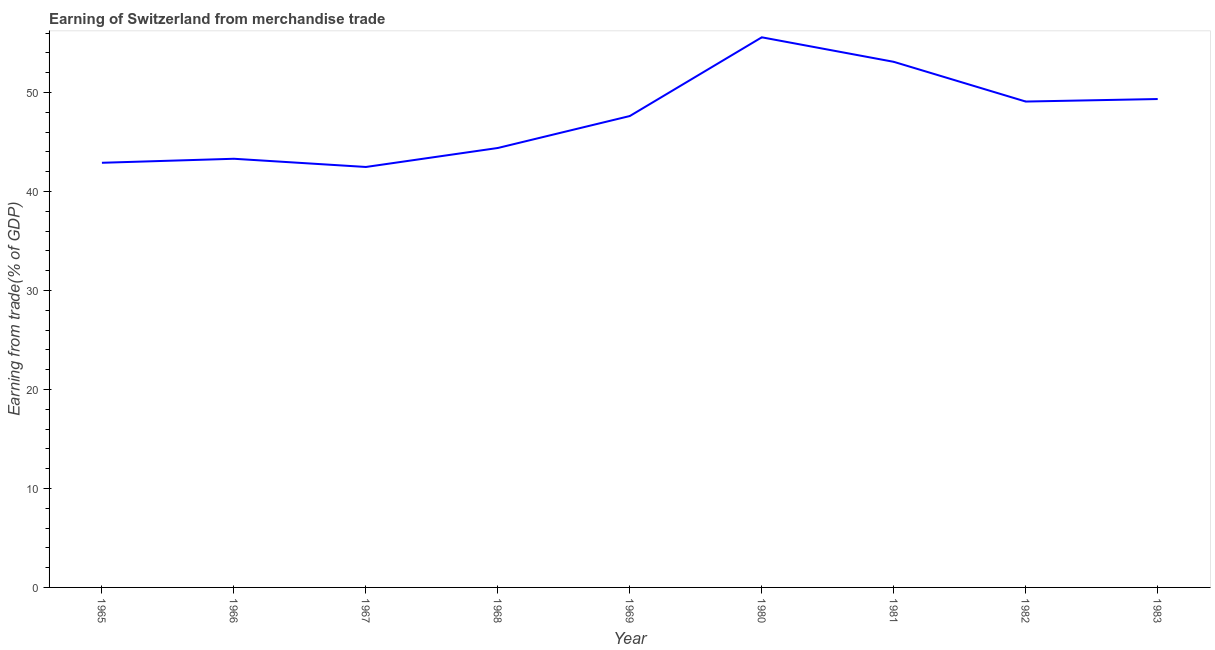What is the earning from merchandise trade in 1966?
Make the answer very short. 43.3. Across all years, what is the maximum earning from merchandise trade?
Your answer should be very brief. 55.57. Across all years, what is the minimum earning from merchandise trade?
Your answer should be compact. 42.48. In which year was the earning from merchandise trade maximum?
Give a very brief answer. 1980. In which year was the earning from merchandise trade minimum?
Offer a very short reply. 1967. What is the sum of the earning from merchandise trade?
Your response must be concise. 427.79. What is the difference between the earning from merchandise trade in 1967 and 1983?
Your response must be concise. -6.86. What is the average earning from merchandise trade per year?
Offer a terse response. 47.53. What is the median earning from merchandise trade?
Make the answer very short. 47.62. In how many years, is the earning from merchandise trade greater than 42 %?
Provide a succinct answer. 9. Do a majority of the years between 1981 and 1969 (inclusive) have earning from merchandise trade greater than 40 %?
Offer a terse response. No. What is the ratio of the earning from merchandise trade in 1967 to that in 1982?
Offer a terse response. 0.87. Is the earning from merchandise trade in 1966 less than that in 1981?
Provide a succinct answer. Yes. What is the difference between the highest and the second highest earning from merchandise trade?
Make the answer very short. 2.48. Is the sum of the earning from merchandise trade in 1968 and 1983 greater than the maximum earning from merchandise trade across all years?
Your answer should be very brief. Yes. What is the difference between the highest and the lowest earning from merchandise trade?
Give a very brief answer. 13.1. How many lines are there?
Provide a short and direct response. 1. What is the difference between two consecutive major ticks on the Y-axis?
Give a very brief answer. 10. Are the values on the major ticks of Y-axis written in scientific E-notation?
Ensure brevity in your answer.  No. Does the graph contain grids?
Offer a terse response. No. What is the title of the graph?
Offer a very short reply. Earning of Switzerland from merchandise trade. What is the label or title of the Y-axis?
Your response must be concise. Earning from trade(% of GDP). What is the Earning from trade(% of GDP) in 1965?
Your answer should be compact. 42.9. What is the Earning from trade(% of GDP) in 1966?
Give a very brief answer. 43.3. What is the Earning from trade(% of GDP) of 1967?
Keep it short and to the point. 42.48. What is the Earning from trade(% of GDP) in 1968?
Ensure brevity in your answer.  44.39. What is the Earning from trade(% of GDP) in 1969?
Your response must be concise. 47.62. What is the Earning from trade(% of GDP) in 1980?
Provide a short and direct response. 55.57. What is the Earning from trade(% of GDP) in 1981?
Your response must be concise. 53.1. What is the Earning from trade(% of GDP) in 1982?
Your answer should be compact. 49.08. What is the Earning from trade(% of GDP) of 1983?
Your answer should be very brief. 49.34. What is the difference between the Earning from trade(% of GDP) in 1965 and 1966?
Your response must be concise. -0.41. What is the difference between the Earning from trade(% of GDP) in 1965 and 1967?
Make the answer very short. 0.42. What is the difference between the Earning from trade(% of GDP) in 1965 and 1968?
Make the answer very short. -1.49. What is the difference between the Earning from trade(% of GDP) in 1965 and 1969?
Offer a terse response. -4.72. What is the difference between the Earning from trade(% of GDP) in 1965 and 1980?
Offer a very short reply. -12.68. What is the difference between the Earning from trade(% of GDP) in 1965 and 1981?
Provide a succinct answer. -10.2. What is the difference between the Earning from trade(% of GDP) in 1965 and 1982?
Your answer should be very brief. -6.19. What is the difference between the Earning from trade(% of GDP) in 1965 and 1983?
Make the answer very short. -6.44. What is the difference between the Earning from trade(% of GDP) in 1966 and 1967?
Your response must be concise. 0.83. What is the difference between the Earning from trade(% of GDP) in 1966 and 1968?
Ensure brevity in your answer.  -1.09. What is the difference between the Earning from trade(% of GDP) in 1966 and 1969?
Keep it short and to the point. -4.32. What is the difference between the Earning from trade(% of GDP) in 1966 and 1980?
Provide a short and direct response. -12.27. What is the difference between the Earning from trade(% of GDP) in 1966 and 1981?
Your response must be concise. -9.79. What is the difference between the Earning from trade(% of GDP) in 1966 and 1982?
Give a very brief answer. -5.78. What is the difference between the Earning from trade(% of GDP) in 1966 and 1983?
Your answer should be very brief. -6.03. What is the difference between the Earning from trade(% of GDP) in 1967 and 1968?
Give a very brief answer. -1.92. What is the difference between the Earning from trade(% of GDP) in 1967 and 1969?
Provide a short and direct response. -5.15. What is the difference between the Earning from trade(% of GDP) in 1967 and 1980?
Keep it short and to the point. -13.1. What is the difference between the Earning from trade(% of GDP) in 1967 and 1981?
Your response must be concise. -10.62. What is the difference between the Earning from trade(% of GDP) in 1967 and 1982?
Provide a short and direct response. -6.61. What is the difference between the Earning from trade(% of GDP) in 1967 and 1983?
Provide a succinct answer. -6.86. What is the difference between the Earning from trade(% of GDP) in 1968 and 1969?
Your response must be concise. -3.23. What is the difference between the Earning from trade(% of GDP) in 1968 and 1980?
Provide a short and direct response. -11.18. What is the difference between the Earning from trade(% of GDP) in 1968 and 1981?
Your response must be concise. -8.7. What is the difference between the Earning from trade(% of GDP) in 1968 and 1982?
Ensure brevity in your answer.  -4.69. What is the difference between the Earning from trade(% of GDP) in 1968 and 1983?
Keep it short and to the point. -4.95. What is the difference between the Earning from trade(% of GDP) in 1969 and 1980?
Ensure brevity in your answer.  -7.95. What is the difference between the Earning from trade(% of GDP) in 1969 and 1981?
Provide a short and direct response. -5.48. What is the difference between the Earning from trade(% of GDP) in 1969 and 1982?
Your answer should be compact. -1.46. What is the difference between the Earning from trade(% of GDP) in 1969 and 1983?
Your answer should be very brief. -1.72. What is the difference between the Earning from trade(% of GDP) in 1980 and 1981?
Your answer should be very brief. 2.48. What is the difference between the Earning from trade(% of GDP) in 1980 and 1982?
Make the answer very short. 6.49. What is the difference between the Earning from trade(% of GDP) in 1980 and 1983?
Ensure brevity in your answer.  6.24. What is the difference between the Earning from trade(% of GDP) in 1981 and 1982?
Your answer should be compact. 4.01. What is the difference between the Earning from trade(% of GDP) in 1981 and 1983?
Your answer should be compact. 3.76. What is the difference between the Earning from trade(% of GDP) in 1982 and 1983?
Give a very brief answer. -0.25. What is the ratio of the Earning from trade(% of GDP) in 1965 to that in 1966?
Keep it short and to the point. 0.99. What is the ratio of the Earning from trade(% of GDP) in 1965 to that in 1967?
Provide a succinct answer. 1.01. What is the ratio of the Earning from trade(% of GDP) in 1965 to that in 1968?
Keep it short and to the point. 0.97. What is the ratio of the Earning from trade(% of GDP) in 1965 to that in 1969?
Your answer should be compact. 0.9. What is the ratio of the Earning from trade(% of GDP) in 1965 to that in 1980?
Provide a succinct answer. 0.77. What is the ratio of the Earning from trade(% of GDP) in 1965 to that in 1981?
Offer a very short reply. 0.81. What is the ratio of the Earning from trade(% of GDP) in 1965 to that in 1982?
Make the answer very short. 0.87. What is the ratio of the Earning from trade(% of GDP) in 1965 to that in 1983?
Provide a short and direct response. 0.87. What is the ratio of the Earning from trade(% of GDP) in 1966 to that in 1967?
Provide a succinct answer. 1.02. What is the ratio of the Earning from trade(% of GDP) in 1966 to that in 1969?
Make the answer very short. 0.91. What is the ratio of the Earning from trade(% of GDP) in 1966 to that in 1980?
Offer a very short reply. 0.78. What is the ratio of the Earning from trade(% of GDP) in 1966 to that in 1981?
Keep it short and to the point. 0.82. What is the ratio of the Earning from trade(% of GDP) in 1966 to that in 1982?
Your answer should be very brief. 0.88. What is the ratio of the Earning from trade(% of GDP) in 1966 to that in 1983?
Ensure brevity in your answer.  0.88. What is the ratio of the Earning from trade(% of GDP) in 1967 to that in 1968?
Offer a terse response. 0.96. What is the ratio of the Earning from trade(% of GDP) in 1967 to that in 1969?
Make the answer very short. 0.89. What is the ratio of the Earning from trade(% of GDP) in 1967 to that in 1980?
Provide a short and direct response. 0.76. What is the ratio of the Earning from trade(% of GDP) in 1967 to that in 1981?
Your answer should be very brief. 0.8. What is the ratio of the Earning from trade(% of GDP) in 1967 to that in 1982?
Your answer should be compact. 0.86. What is the ratio of the Earning from trade(% of GDP) in 1967 to that in 1983?
Your answer should be compact. 0.86. What is the ratio of the Earning from trade(% of GDP) in 1968 to that in 1969?
Provide a short and direct response. 0.93. What is the ratio of the Earning from trade(% of GDP) in 1968 to that in 1980?
Ensure brevity in your answer.  0.8. What is the ratio of the Earning from trade(% of GDP) in 1968 to that in 1981?
Offer a very short reply. 0.84. What is the ratio of the Earning from trade(% of GDP) in 1968 to that in 1982?
Ensure brevity in your answer.  0.9. What is the ratio of the Earning from trade(% of GDP) in 1968 to that in 1983?
Make the answer very short. 0.9. What is the ratio of the Earning from trade(% of GDP) in 1969 to that in 1980?
Your answer should be very brief. 0.86. What is the ratio of the Earning from trade(% of GDP) in 1969 to that in 1981?
Ensure brevity in your answer.  0.9. What is the ratio of the Earning from trade(% of GDP) in 1980 to that in 1981?
Your response must be concise. 1.05. What is the ratio of the Earning from trade(% of GDP) in 1980 to that in 1982?
Provide a succinct answer. 1.13. What is the ratio of the Earning from trade(% of GDP) in 1980 to that in 1983?
Keep it short and to the point. 1.13. What is the ratio of the Earning from trade(% of GDP) in 1981 to that in 1982?
Offer a very short reply. 1.08. What is the ratio of the Earning from trade(% of GDP) in 1981 to that in 1983?
Provide a succinct answer. 1.08. What is the ratio of the Earning from trade(% of GDP) in 1982 to that in 1983?
Offer a very short reply. 0.99. 